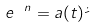Convert formula to latex. <formula><loc_0><loc_0><loc_500><loc_500>e ^ { \ n } = a ( t ) \dot { \psi }</formula> 